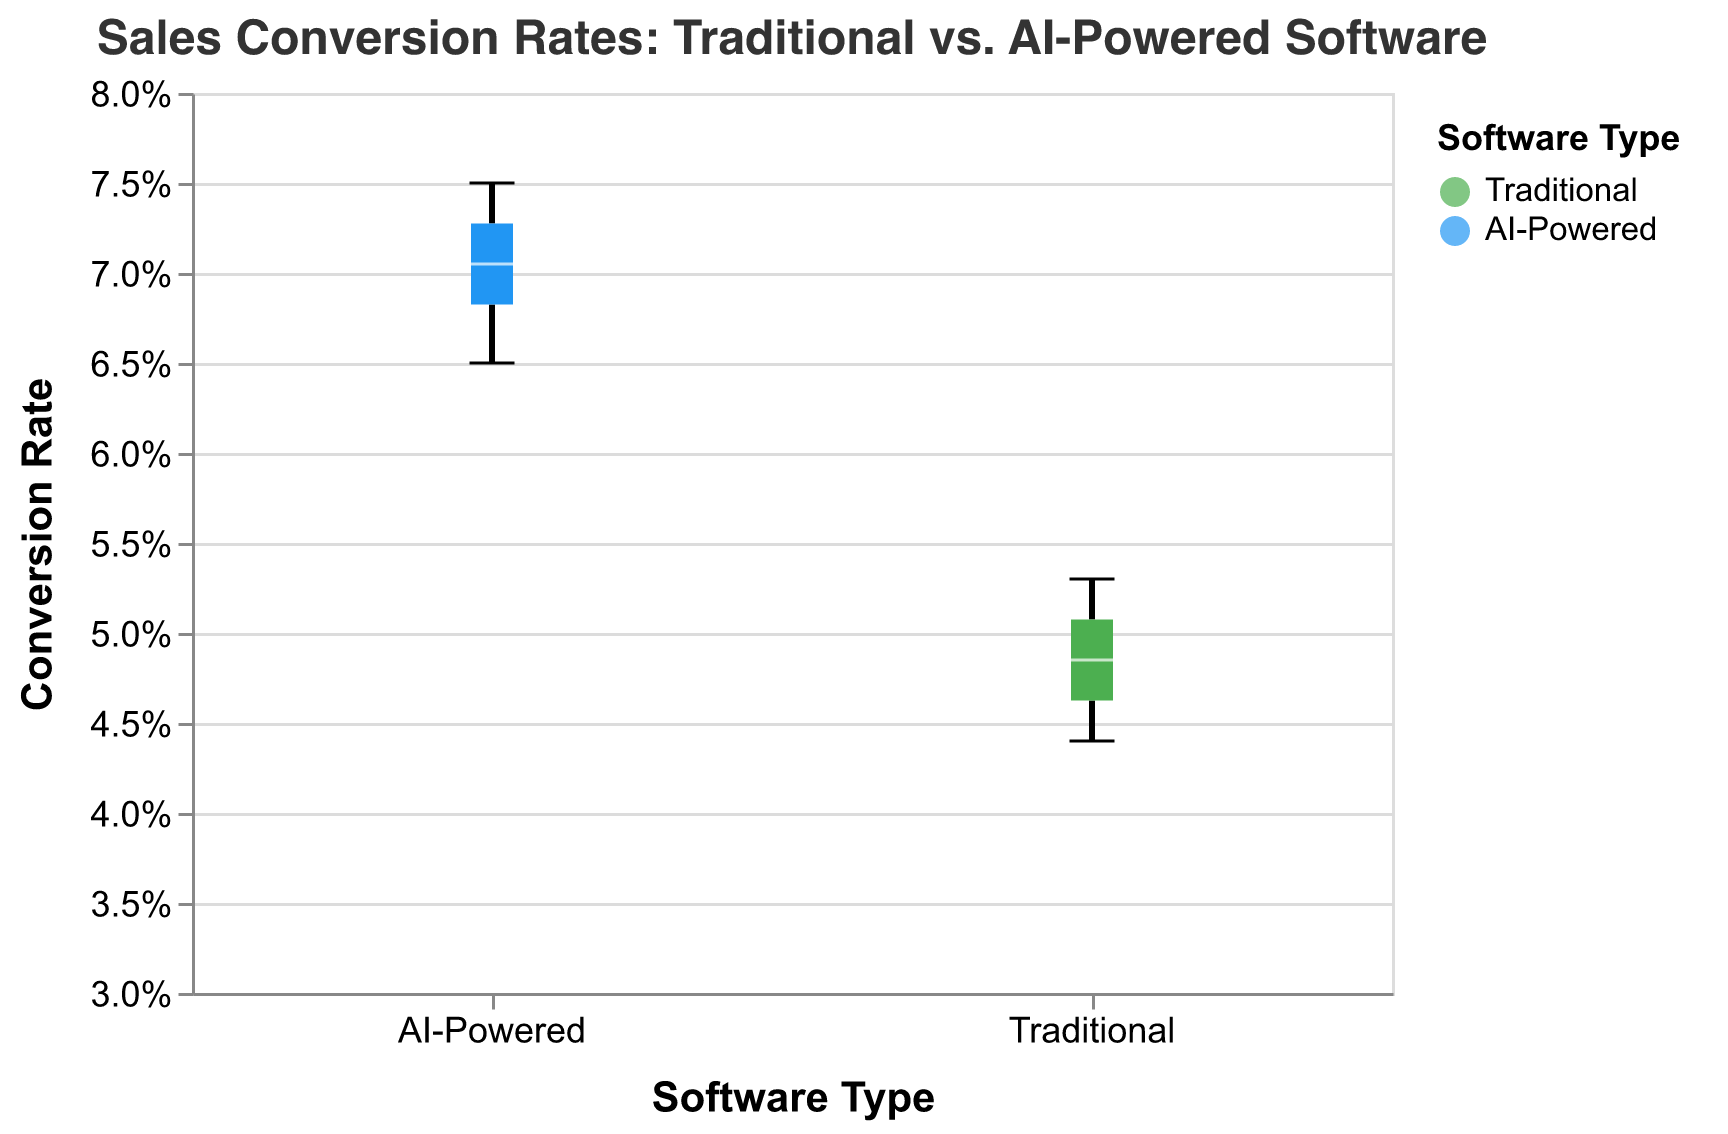What is the title of the figure? The title is displayed at the top of the figure and reads: "Sales Conversion Rates: Traditional vs. AI-Powered Software"
Answer: Sales Conversion Rates: Traditional vs. AI-Powered Software What are the two software types compared in the figure? The x-axis indicates the two categories being compared, which are "Traditional" and "AI-Powered" software.
Answer: Traditional, AI-Powered What is the range of the y-axis in the figure? The y-axis ranges from 0.03 to 0.08, which is evident from the labels along the y-axis.
Answer: 0.03, 0.08 What is the median conversion rate for traditional sales software? The median line inside the "Traditional" boxplot indicates the median conversion rate for traditional sales software.
Answer: 0.049 Which software type has the higher median conversion rate? Comparing the median lines inside the two boxes, the median line for "AI-Powered" software is higher than for "Traditional" software.
Answer: AI-Powered What is the interquartile range (IQR) for AI-powered software conversion rates? The IQR is the range between the first quartile (Q1) and the third quartile (Q3) within the box plot of "AI-Powered" software. Q1 is around 0.068, and Q3 is around 0.073, so IQR is 0.073 - 0.068.
Answer: 0.005 How many companies' conversion rates are represented for each software type? By counting the data points in each category, each software type has conversion rates for 10 companies.
Answer: 10 Which company has the highest conversion rate for AI-powered software? Referring to the highest value in the "AI-Powered" box plot, Greenfield Ventures has the highest conversion rate of 0.075.
Answer: Greenfield Ventures Compare the minimum conversion rates between the traditional and AI-powered software groups. Which has the lower minimum rate? The minimum value in the "Traditional" box plot is 0.044, and the minimum value in the "AI-Powered" box plot is 0.065. Hence, the traditional software group has the lower minimum rate.
Answer: Traditional What is the difference between the maximum conversion rates of the AI-powered and traditional software? The maximum conversion rate for AI-powered software is 0.075, and for traditional software is 0.053. The difference is 0.075 - 0.053.
Answer: 0.022 